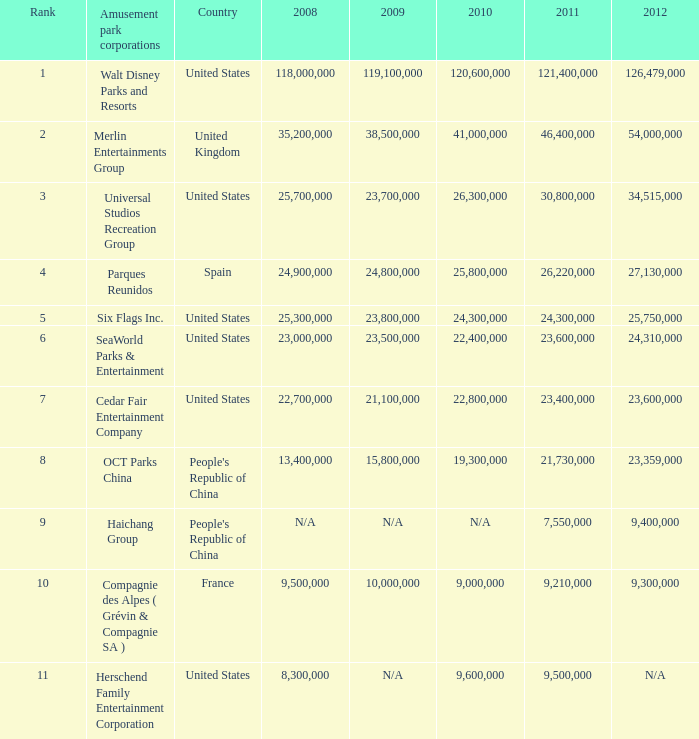What is the Rank listed for the attendance of 2010 of 9,000,000 and 2011 larger than 9,210,000? None. 